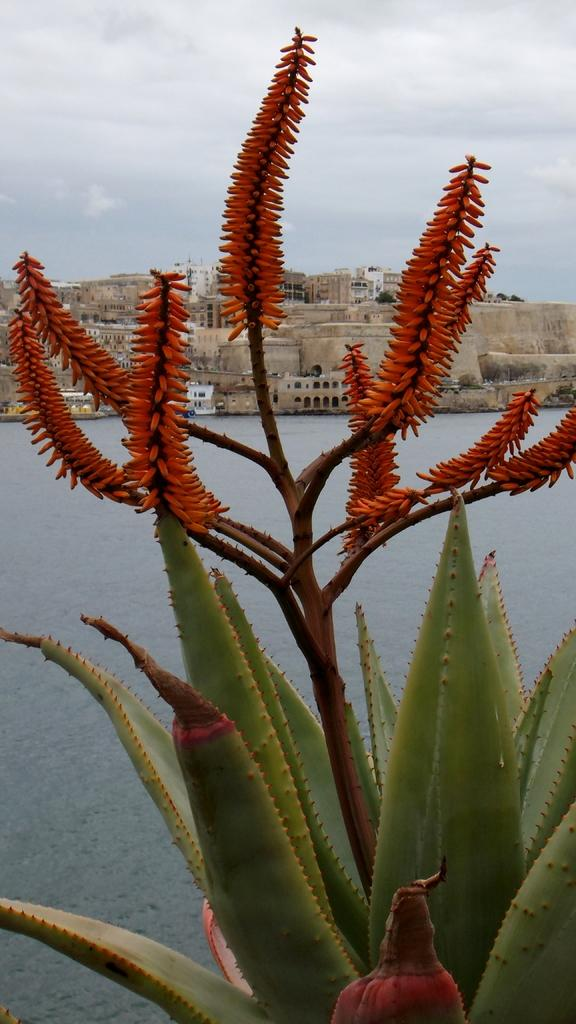What is present in the image? There is a plant in the image. Can you describe the colors of the plant? The plant has green, brown, and orange colors. What can be seen in the background of the image? There is water, a boat with people in it, buildings, and the sky visible in the background of the image. Can you see a snake slithering around the plant in the image? There is no snake present in the image. What type of frame is the image displayed in? The image itself does not show a frame, as it is a description of the contents of the image. 